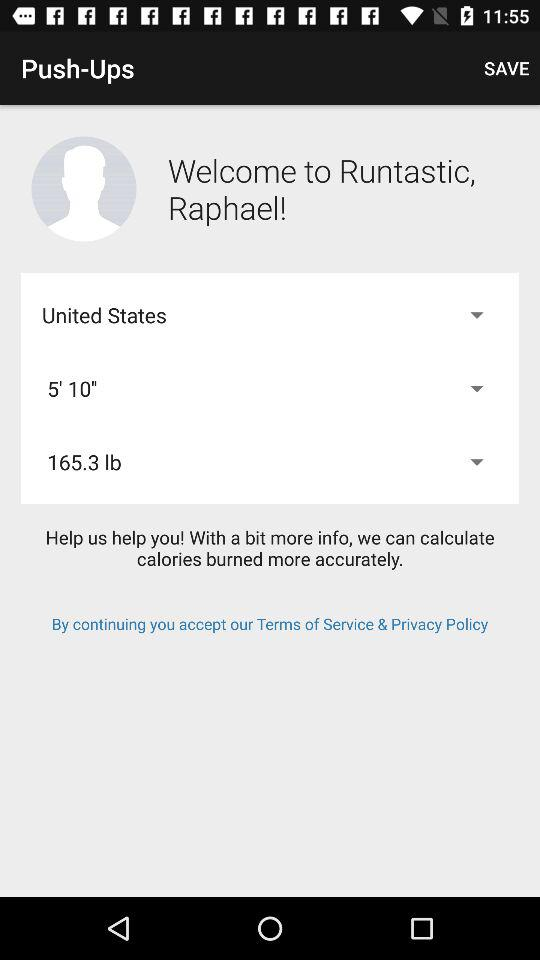What is the selected weight in lb? The selected weight in lb is 165.3. 